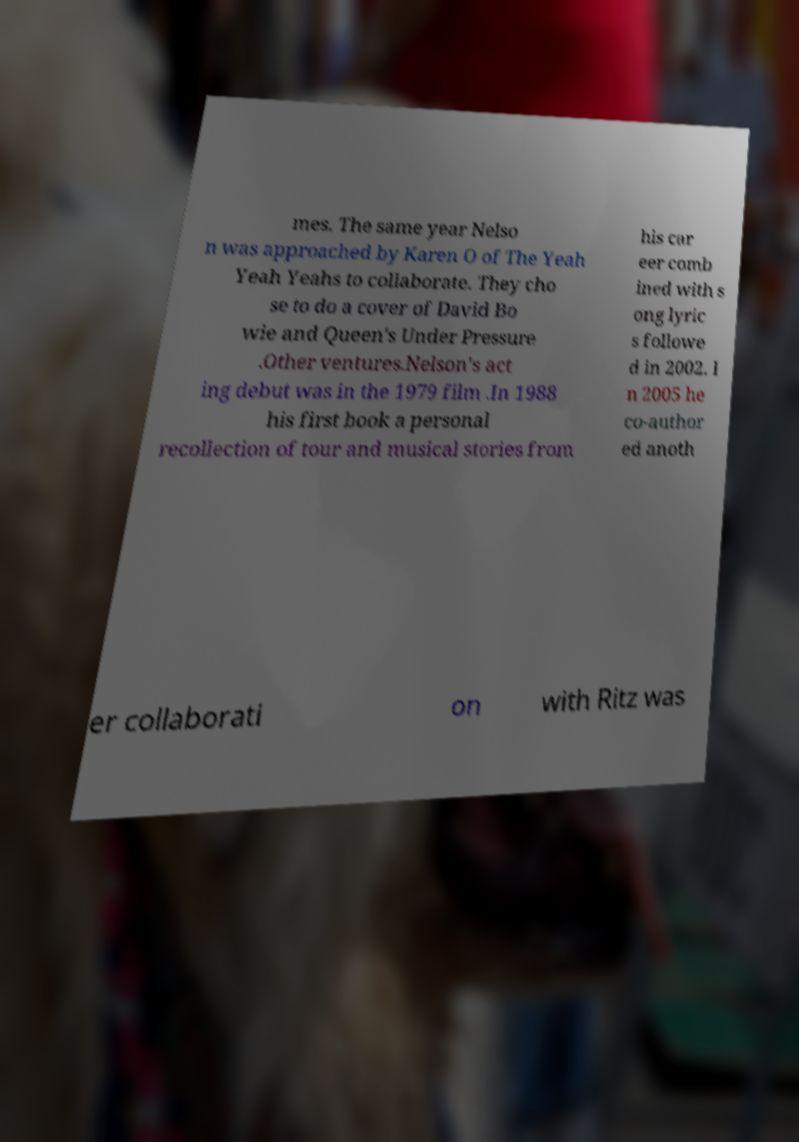I need the written content from this picture converted into text. Can you do that? mes. The same year Nelso n was approached by Karen O of The Yeah Yeah Yeahs to collaborate. They cho se to do a cover of David Bo wie and Queen's Under Pressure .Other ventures.Nelson's act ing debut was in the 1979 film .In 1988 his first book a personal recollection of tour and musical stories from his car eer comb ined with s ong lyric s followe d in 2002. I n 2005 he co-author ed anoth er collaborati on with Ritz was 